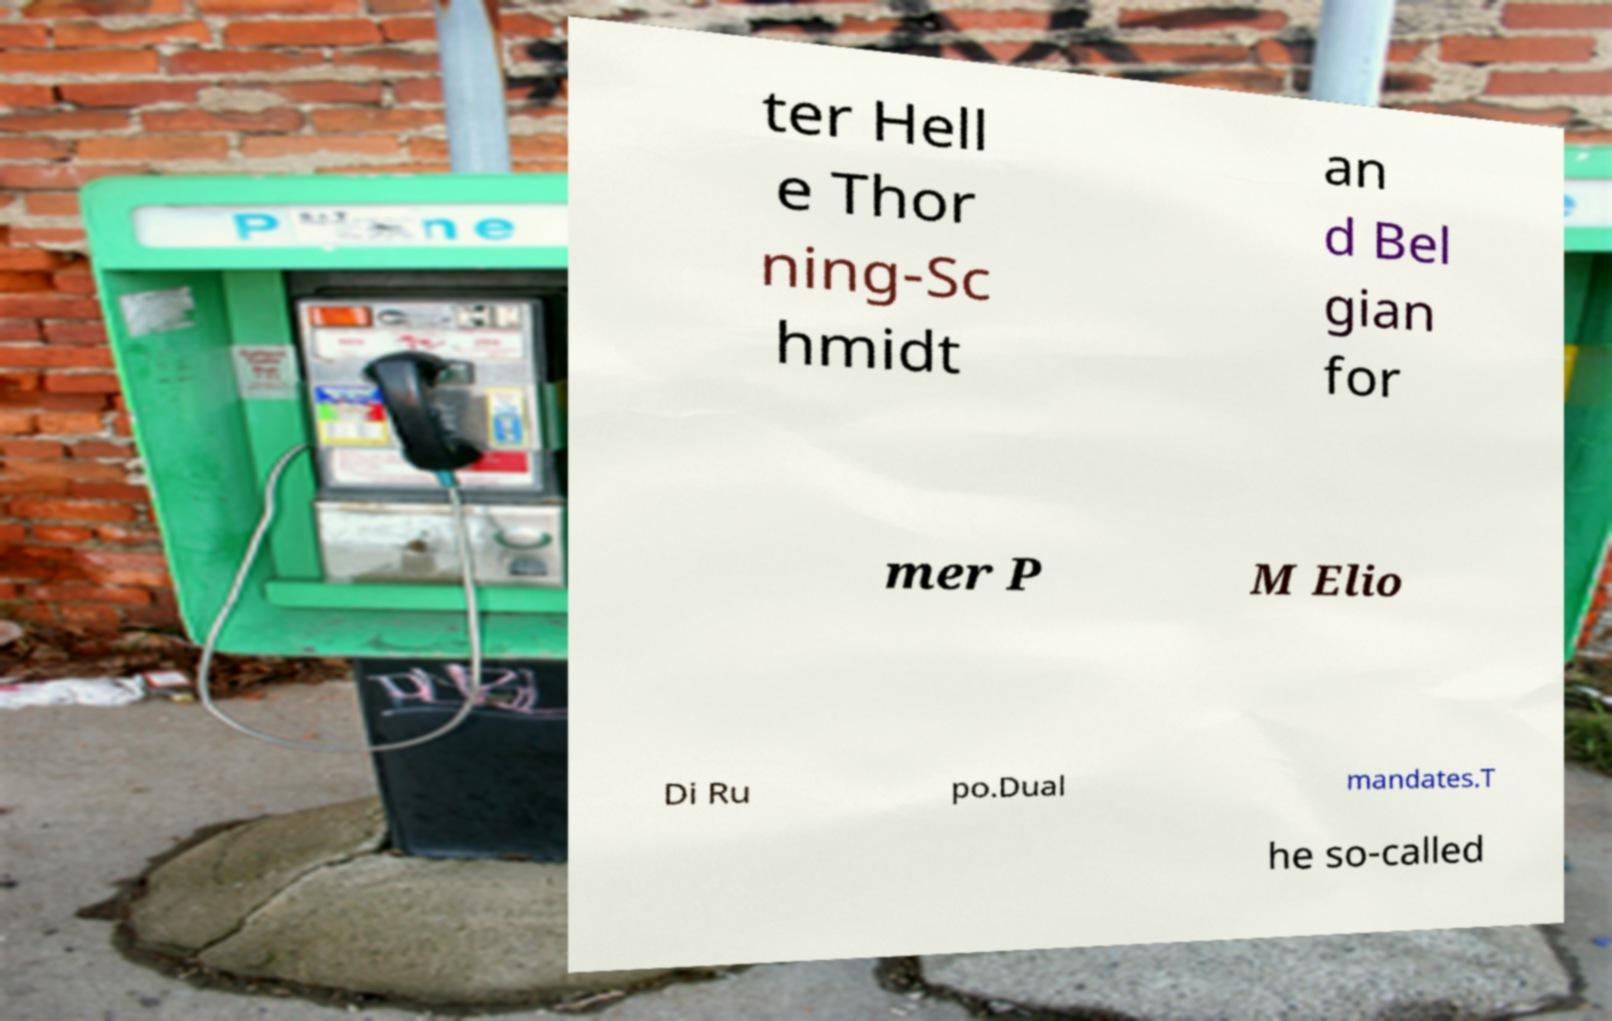Can you accurately transcribe the text from the provided image for me? ter Hell e Thor ning-Sc hmidt an d Bel gian for mer P M Elio Di Ru po.Dual mandates.T he so-called 